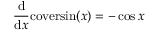Convert formula to latex. <formula><loc_0><loc_0><loc_500><loc_500>{ \frac { d } { d x } } c o v e r \sin ( x ) = - \cos { x }</formula> 